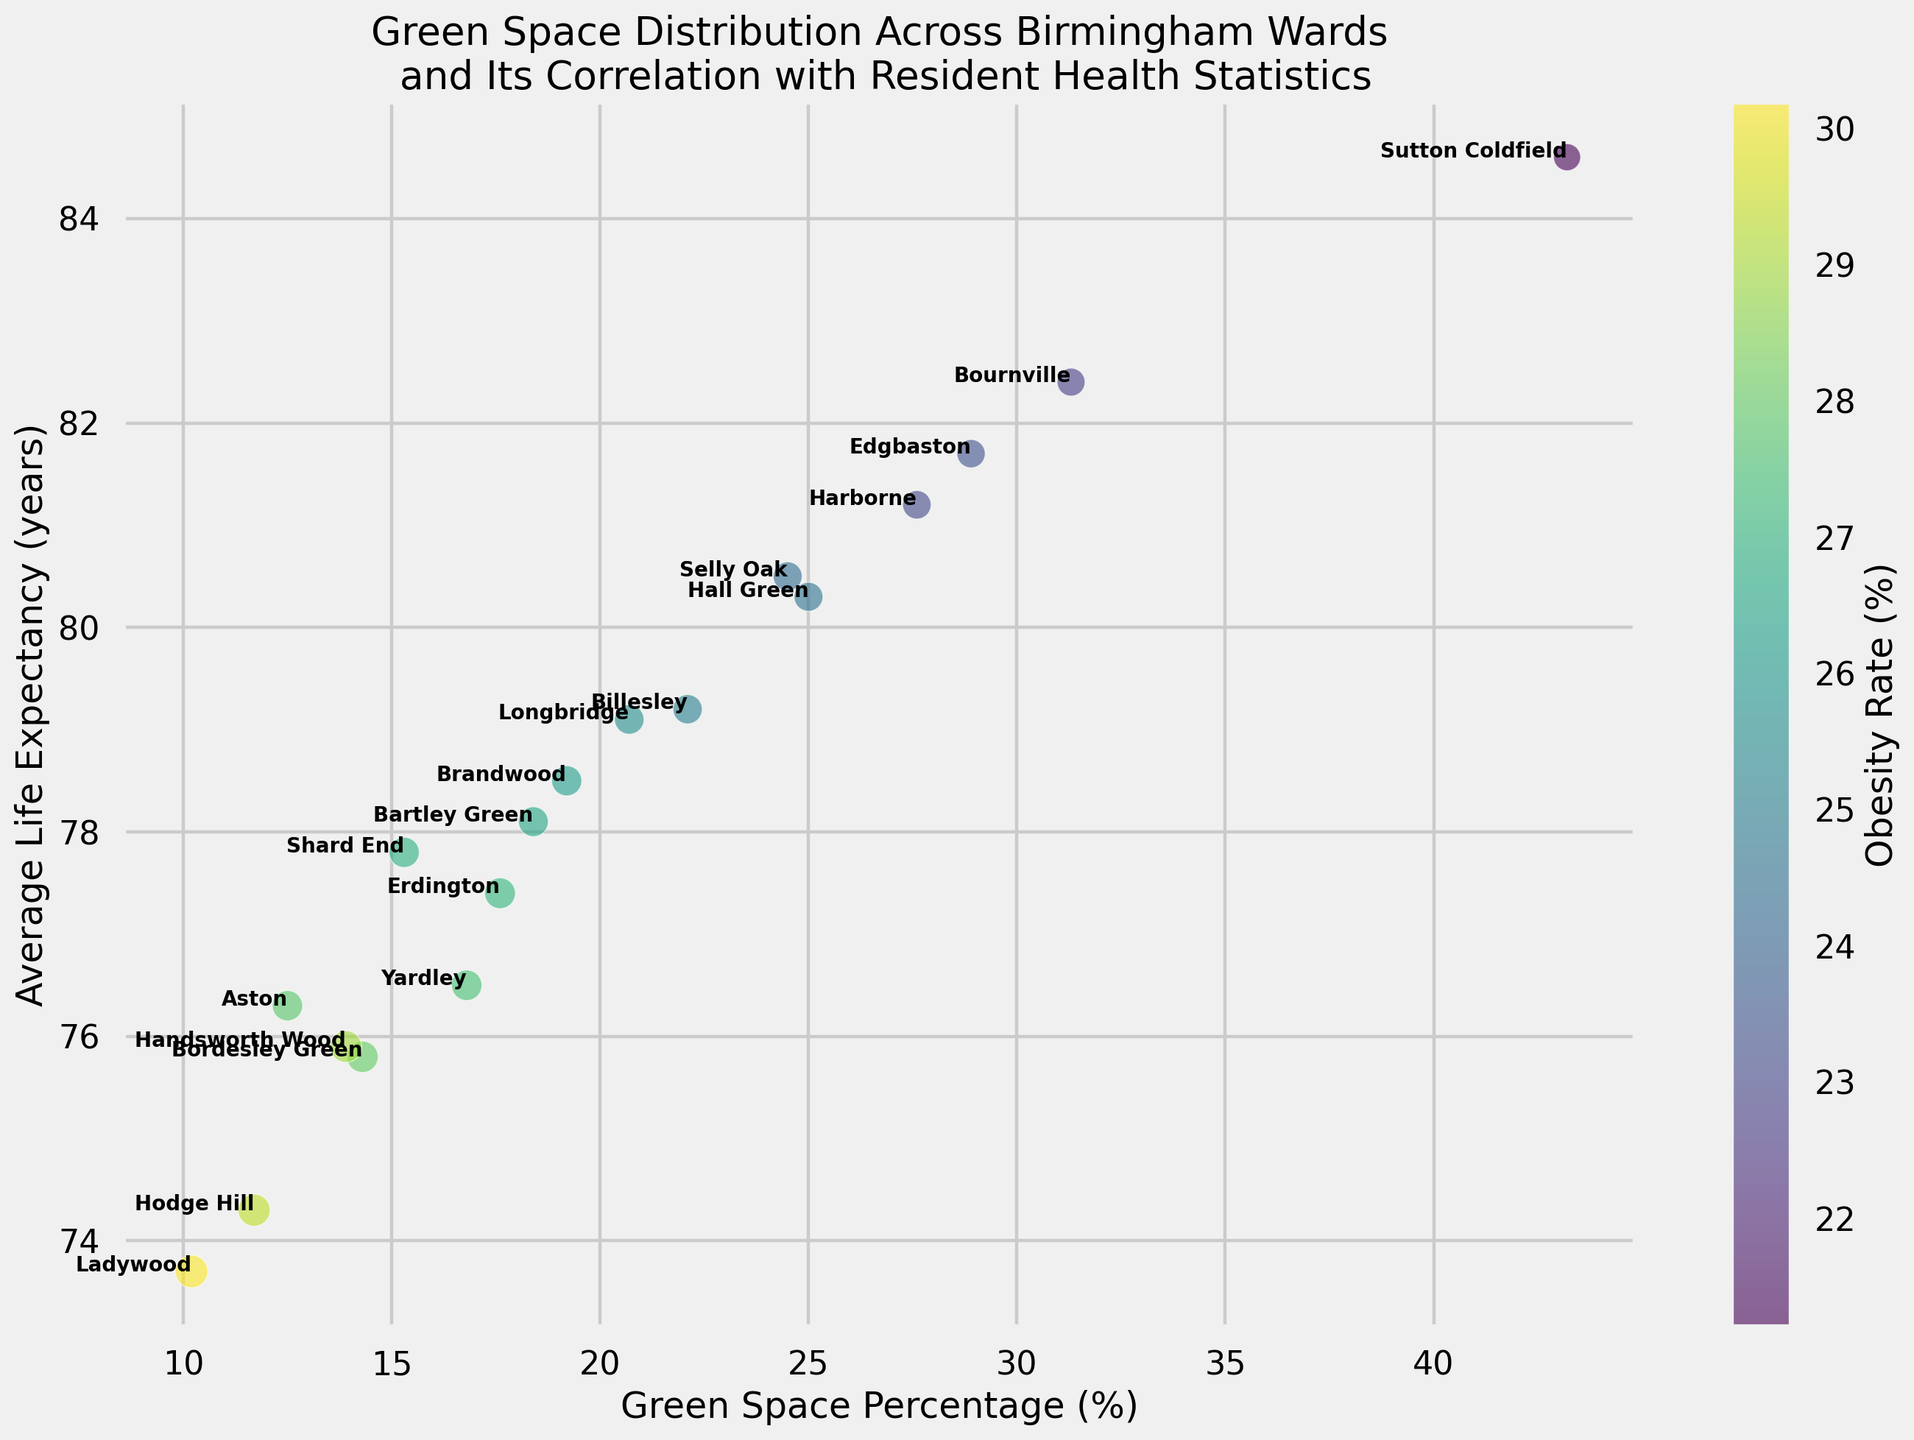What's the ward with the highest average life expectancy? To find the ward with the highest average life expectancy, look at the vertical axis of the scatter plot and identify the point that is the highest on that axis. The annotation for this point will give the name of the ward.
Answer: Sutton Coldfield Which wards have more than 25% green space? To identify the wards with more than 25% green space, look along the horizontal axis and find the points that are beyond the 25% mark. The annotations of these points will give the names of the wards.
Answer: Bournville, Edgbaston, Harborne, Hall Green, Sutton Coldfield Which ward has the highest obesity rate and what is its green space percentage? To find the ward with the highest obesity rate, look at the color bar; darker colors indicate higher obesity rates. Locate the darkest point on the scatter plot and read the annotation for the ward's name. Then read the associated green space percentage from the horizontal axis for that point.
Answer: Ladywood, 10.2% What's the average green space percentage for wards with an average life expectancy above 80 years? Identify the wards with an average life expectancy above 80 years using the vertical axis. Then read their green space percentages from the horizontal axis. Sum these percentages and divide by the number of such wards. Wards: Bournville (31.3), Edgbaston (28.9), Hall Green (25.0), Harborne (27.6), Sutton Coldfield (43.2). Sum: 31.3 + 28.9 + 25.0 + 27.6 + 43.2 = 156. Divide by 5 wards.
Answer: 31.2% Compare the wards Aston and Bournville in terms of mental health rate and average life expectancy. Look at the annotations for Aston and Bournville on the scatter plot. Read their mental health rate and average life expectancy. Aston: 22.1% mental health rate, 76.3 years life expectancy. Bournville: 18.7% mental health rate, 82.4 years life expectancy.
Answer: Aston: 22.1%, 76.3 years; Bournville: 18.7%, 82.4 years Which ward has the largest area (size) of the circle, and what does the size represent? The size of the circles represents the mental health rate. Find the largest circle on the scatter plot and identify the ward through its annotation.
Answer: Hodge Hill, it represents the mental health rate of 24.8% What's the relationship between green space percentage and average life expectancy based on the scatter plot? Observing the overall trend of the points on the scatter plot, check whether the points are moving upwards (indicating a positive relationship) as they move to the right (increasing green space percentage).
Answer: Generally positive Which ward has the lowest life expectancy and what is its green space percentage? Identify the ward with the lowest life expectancy by looking at the point lowest on the vertical axis. Read the ward's name and its green space percentage from the horizontal axis.
Answer: Ladywood, 10.2% 